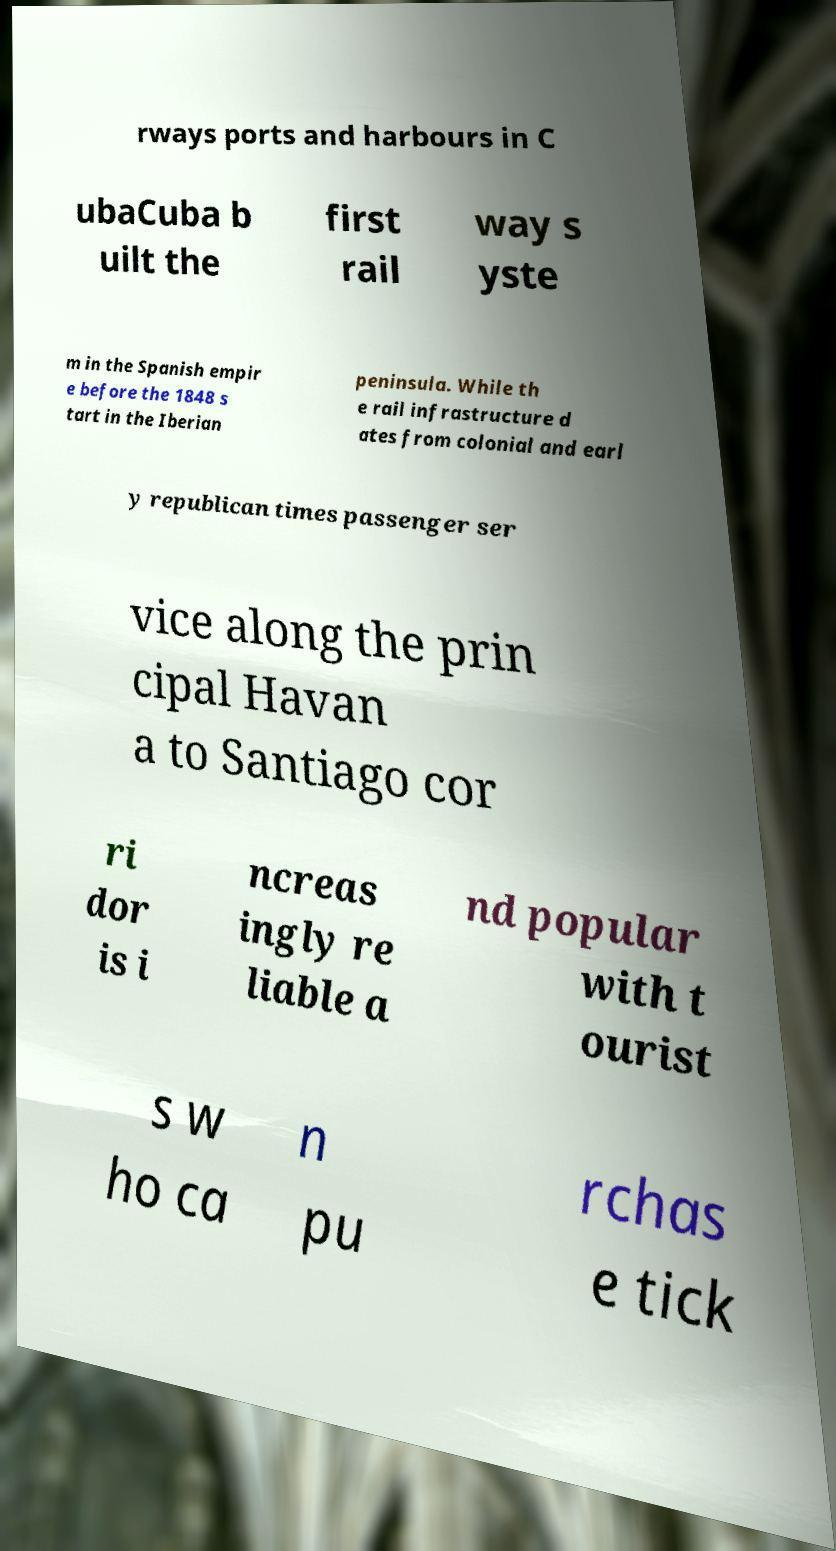What messages or text are displayed in this image? I need them in a readable, typed format. rways ports and harbours in C ubaCuba b uilt the first rail way s yste m in the Spanish empir e before the 1848 s tart in the Iberian peninsula. While th e rail infrastructure d ates from colonial and earl y republican times passenger ser vice along the prin cipal Havan a to Santiago cor ri dor is i ncreas ingly re liable a nd popular with t ourist s w ho ca n pu rchas e tick 